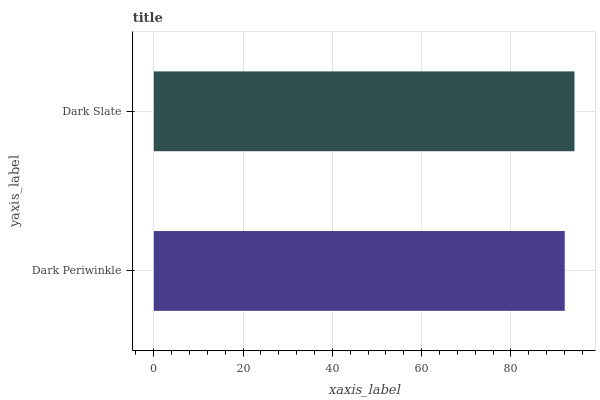Is Dark Periwinkle the minimum?
Answer yes or no. Yes. Is Dark Slate the maximum?
Answer yes or no. Yes. Is Dark Slate the minimum?
Answer yes or no. No. Is Dark Slate greater than Dark Periwinkle?
Answer yes or no. Yes. Is Dark Periwinkle less than Dark Slate?
Answer yes or no. Yes. Is Dark Periwinkle greater than Dark Slate?
Answer yes or no. No. Is Dark Slate less than Dark Periwinkle?
Answer yes or no. No. Is Dark Slate the high median?
Answer yes or no. Yes. Is Dark Periwinkle the low median?
Answer yes or no. Yes. Is Dark Periwinkle the high median?
Answer yes or no. No. Is Dark Slate the low median?
Answer yes or no. No. 